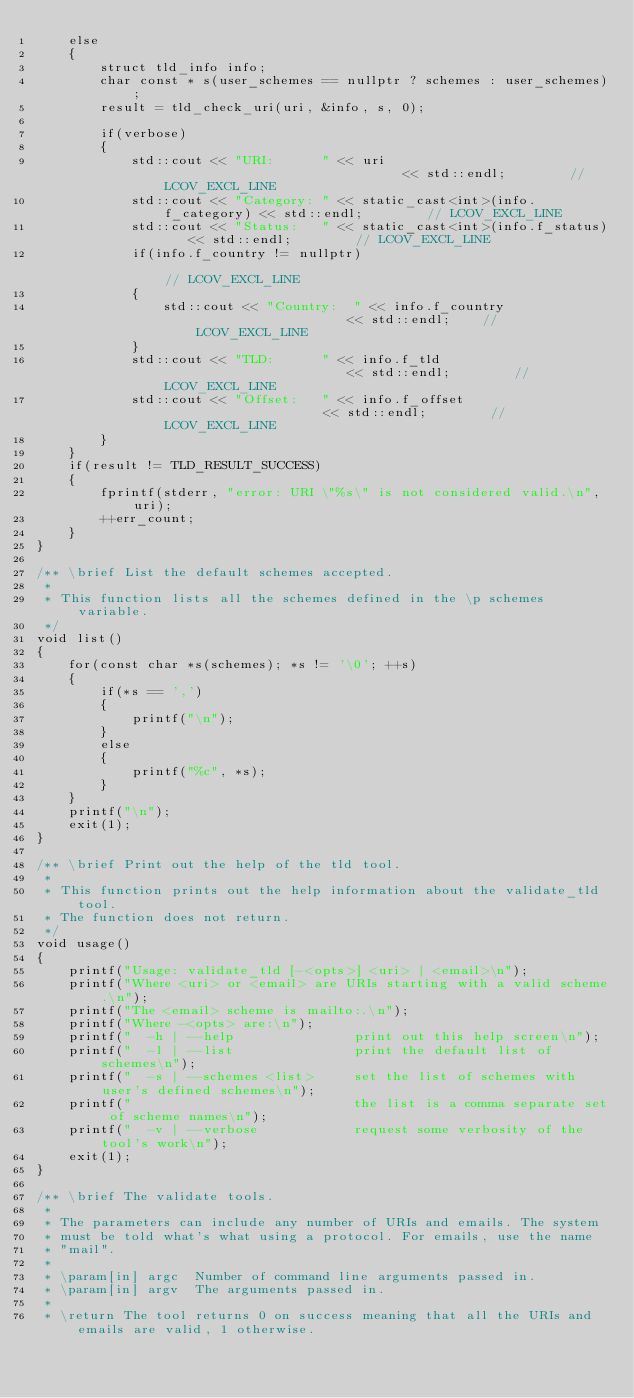Convert code to text. <code><loc_0><loc_0><loc_500><loc_500><_C++_>    else
    {
        struct tld_info info;
        char const * s(user_schemes == nullptr ? schemes : user_schemes);
        result = tld_check_uri(uri, &info, s, 0);

        if(verbose)
        {
            std::cout << "URI:      " << uri                               << std::endl;        // LCOV_EXCL_LINE
            std::cout << "Category: " << static_cast<int>(info.f_category) << std::endl;        // LCOV_EXCL_LINE
            std::cout << "Status:   " << static_cast<int>(info.f_status)   << std::endl;        // LCOV_EXCL_LINE
            if(info.f_country != nullptr)                                                       // LCOV_EXCL_LINE
            {
                std::cout << "Country:  " << info.f_country                    << std::endl;    // LCOV_EXCL_LINE
            }
            std::cout << "TLD:      " << info.f_tld                        << std::endl;        // LCOV_EXCL_LINE
            std::cout << "Offset:   " << info.f_offset                     << std::endl;        // LCOV_EXCL_LINE
        }
    }
    if(result != TLD_RESULT_SUCCESS)
    {
        fprintf(stderr, "error: URI \"%s\" is not considered valid.\n", uri);
        ++err_count;
    }
}

/** \brief List the default schemes accepted.
 *
 * This function lists all the schemes defined in the \p schemes variable.
 */
void list()
{
    for(const char *s(schemes); *s != '\0'; ++s)
    {
        if(*s == ',')
        {
            printf("\n");
        }
        else
        {
            printf("%c", *s);
        }
    }
    printf("\n");
    exit(1);
}

/** \brief Print out the help of the tld tool.
 *
 * This function prints out the help information about the validate_tld tool.
 * The function does not return.
 */
void usage()
{
    printf("Usage: validate_tld [-<opts>] <uri> | <email>\n");
    printf("Where <uri> or <email> are URIs starting with a valid scheme.\n");
    printf("The <email> scheme is mailto:.\n");
    printf("Where -<opts> are:\n");
    printf("  -h | --help               print out this help screen\n");
    printf("  -l | --list               print the default list of schemes\n");
    printf("  -s | --schemes <list>     set the list of schemes with user's defined schemes\n");
    printf("                            the list is a comma separate set of scheme names\n");
    printf("  -v | --verbose            request some verbosity of the tool's work\n");
    exit(1);
}

/** \brief The validate tools.
 *
 * The parameters can include any number of URIs and emails. The system
 * must be told what's what using a protocol. For emails, use the name
 * "mail".
 *
 * \param[in] argc  Number of command line arguments passed in.
 * \param[in] argv  The arguments passed in.
 *
 * \return The tool returns 0 on success meaning that all the URIs and emails are valid, 1 otherwise.</code> 